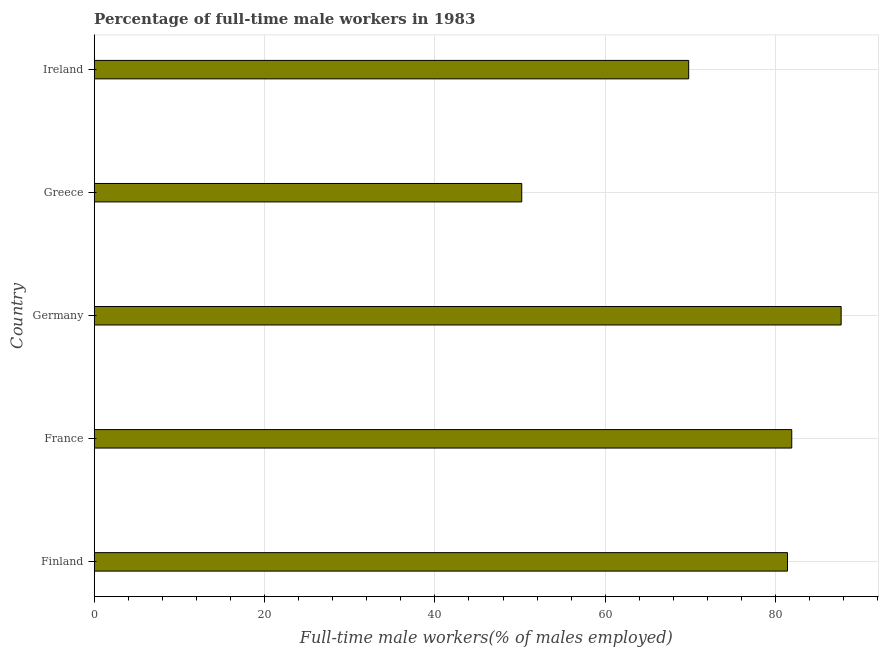What is the title of the graph?
Keep it short and to the point. Percentage of full-time male workers in 1983. What is the label or title of the X-axis?
Your answer should be very brief. Full-time male workers(% of males employed). What is the percentage of full-time male workers in Germany?
Your answer should be compact. 87.7. Across all countries, what is the maximum percentage of full-time male workers?
Give a very brief answer. 87.7. Across all countries, what is the minimum percentage of full-time male workers?
Your answer should be compact. 50.2. In which country was the percentage of full-time male workers maximum?
Your response must be concise. Germany. What is the sum of the percentage of full-time male workers?
Offer a very short reply. 371. What is the difference between the percentage of full-time male workers in Finland and Ireland?
Ensure brevity in your answer.  11.6. What is the average percentage of full-time male workers per country?
Your response must be concise. 74.2. What is the median percentage of full-time male workers?
Ensure brevity in your answer.  81.4. What is the ratio of the percentage of full-time male workers in Finland to that in Ireland?
Ensure brevity in your answer.  1.17. Is the percentage of full-time male workers in Germany less than that in Ireland?
Your response must be concise. No. Is the difference between the percentage of full-time male workers in France and Greece greater than the difference between any two countries?
Your answer should be very brief. No. Is the sum of the percentage of full-time male workers in France and Germany greater than the maximum percentage of full-time male workers across all countries?
Your response must be concise. Yes. What is the difference between the highest and the lowest percentage of full-time male workers?
Offer a very short reply. 37.5. In how many countries, is the percentage of full-time male workers greater than the average percentage of full-time male workers taken over all countries?
Your response must be concise. 3. How many countries are there in the graph?
Make the answer very short. 5. What is the difference between two consecutive major ticks on the X-axis?
Offer a terse response. 20. What is the Full-time male workers(% of males employed) of Finland?
Your answer should be compact. 81.4. What is the Full-time male workers(% of males employed) of France?
Ensure brevity in your answer.  81.9. What is the Full-time male workers(% of males employed) of Germany?
Make the answer very short. 87.7. What is the Full-time male workers(% of males employed) of Greece?
Offer a very short reply. 50.2. What is the Full-time male workers(% of males employed) in Ireland?
Keep it short and to the point. 69.8. What is the difference between the Full-time male workers(% of males employed) in Finland and Germany?
Your answer should be very brief. -6.3. What is the difference between the Full-time male workers(% of males employed) in Finland and Greece?
Provide a short and direct response. 31.2. What is the difference between the Full-time male workers(% of males employed) in Finland and Ireland?
Keep it short and to the point. 11.6. What is the difference between the Full-time male workers(% of males employed) in France and Greece?
Your response must be concise. 31.7. What is the difference between the Full-time male workers(% of males employed) in Germany and Greece?
Make the answer very short. 37.5. What is the difference between the Full-time male workers(% of males employed) in Germany and Ireland?
Keep it short and to the point. 17.9. What is the difference between the Full-time male workers(% of males employed) in Greece and Ireland?
Offer a very short reply. -19.6. What is the ratio of the Full-time male workers(% of males employed) in Finland to that in Germany?
Your answer should be very brief. 0.93. What is the ratio of the Full-time male workers(% of males employed) in Finland to that in Greece?
Your answer should be very brief. 1.62. What is the ratio of the Full-time male workers(% of males employed) in Finland to that in Ireland?
Your response must be concise. 1.17. What is the ratio of the Full-time male workers(% of males employed) in France to that in Germany?
Your answer should be compact. 0.93. What is the ratio of the Full-time male workers(% of males employed) in France to that in Greece?
Your answer should be very brief. 1.63. What is the ratio of the Full-time male workers(% of males employed) in France to that in Ireland?
Provide a short and direct response. 1.17. What is the ratio of the Full-time male workers(% of males employed) in Germany to that in Greece?
Provide a succinct answer. 1.75. What is the ratio of the Full-time male workers(% of males employed) in Germany to that in Ireland?
Give a very brief answer. 1.26. What is the ratio of the Full-time male workers(% of males employed) in Greece to that in Ireland?
Ensure brevity in your answer.  0.72. 